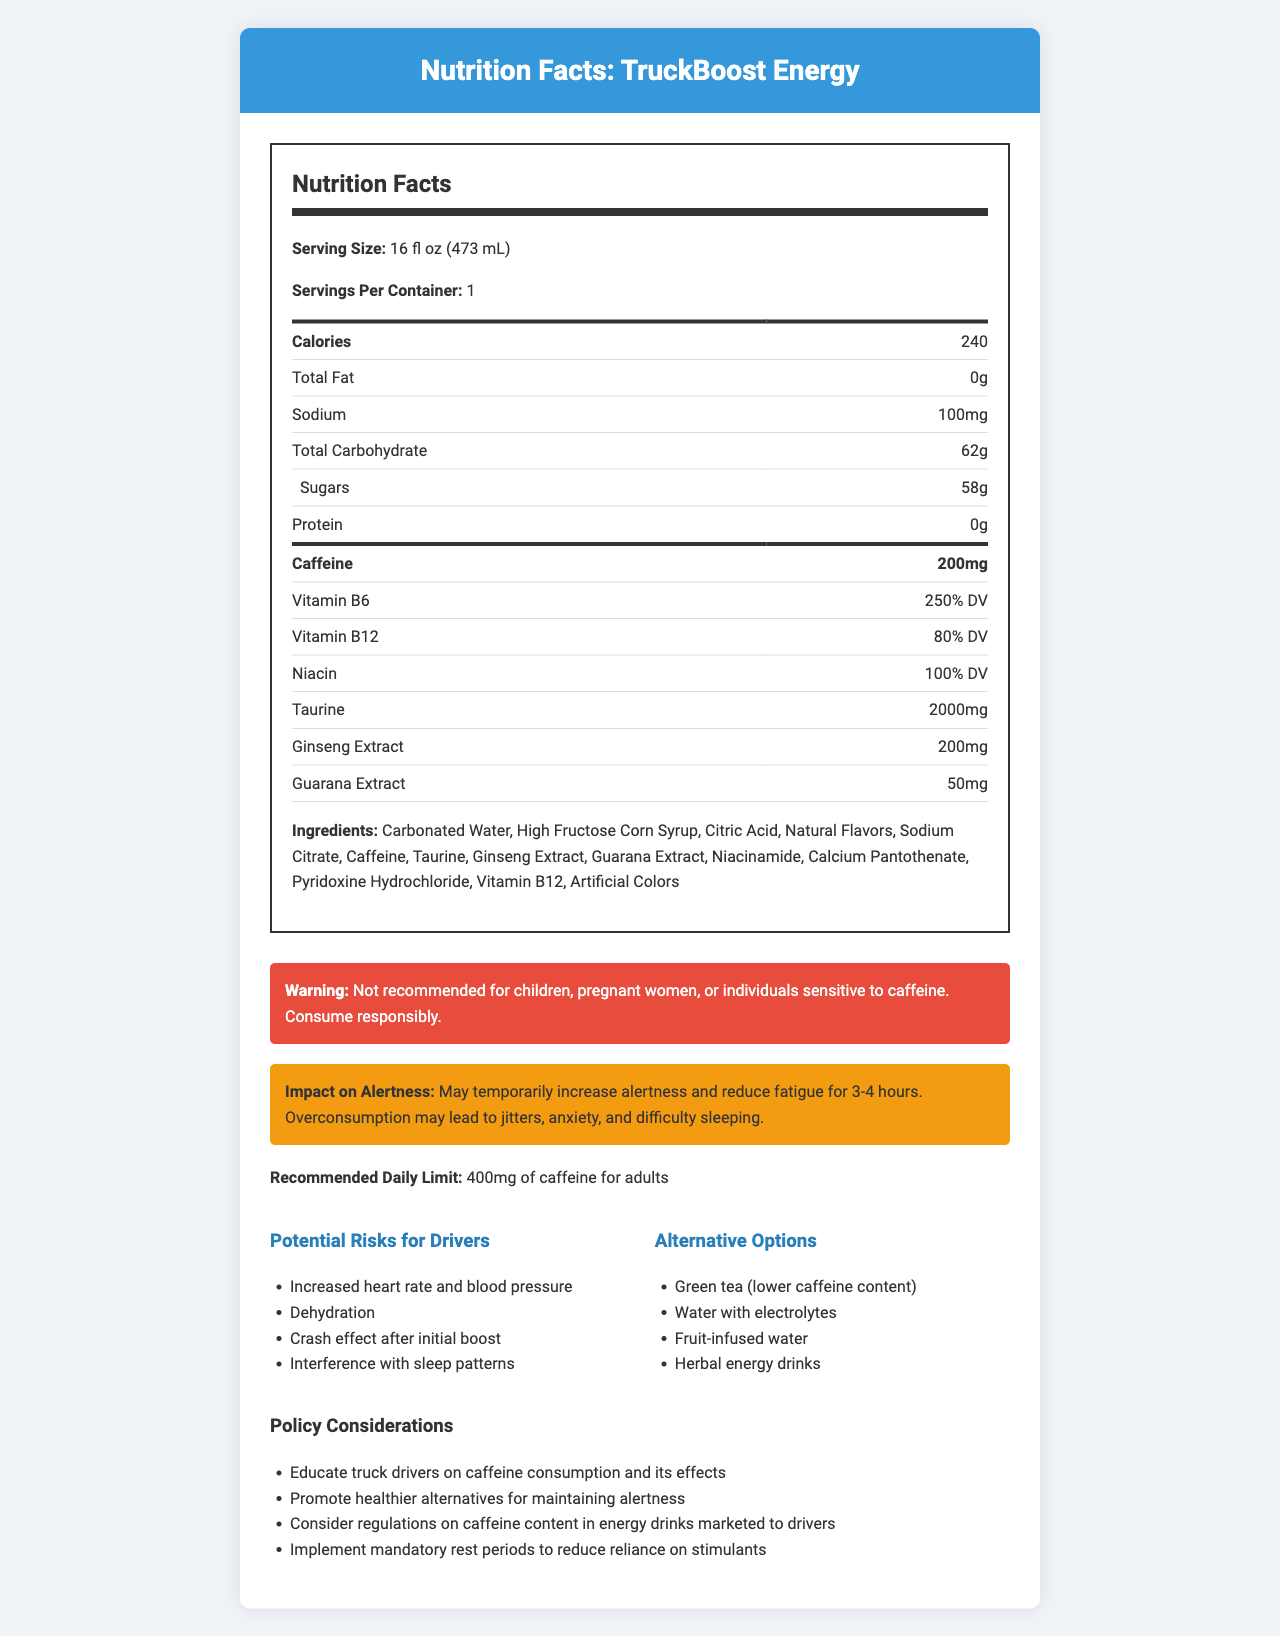What is the serving size of TruckBoost Energy? The serving size is clearly listed at the top of the Nutrition Facts label.
Answer: 16 fl oz (473 mL) How many grams of sugar are in one serving of TruckBoost Energy? The sugar content is listed under the Total Carbohydrate section as 58 grams.
Answer: 58g How much caffeine does each can of TruckBoost Energy contain? The caffeine content is highlighted in the Nutrition Facts section with 200mg.
Answer: 200mg What is the sodium content per serving? The sodium content is stated as 100mg in the Nutrition Facts label.
Answer: 100mg How many calories are in one serving of TruckBoost Energy? The calorie content is listed at the top of the Nutrition Facts label with 240 calories.
Answer: 240 What percentage of the Daily Value of Vitamin B6 is in TruckBoost Energy? The Vitamin B6 content is given as 250% of the Daily Value in the Nutrition Facts.
Answer: 250% DV What is the recommended daily limit for caffeine intake? The recommended daily limit for caffeine is mentioned towards the bottom of the document.
Answer: 400mg of caffeine for adults Which of the following is NOT an ingredient in TruckBoost Energy? A. Citric Acid B. Ginseng Extract C. Maltodextrin D. High Fructose Corn Syrup The list of ingredients includes Citric Acid, Ginseng Extract, and High Fructose Corn Syrup but does not include Maltodextrin.
Answer: C. Maltodextrin Which of the following are potential risks for drivers consuming TruckBoost Energy? (Select all that apply) 1. Increased heart rate and blood pressure 2. Enhanced cognitive function 3. Dehydration 4. Improved sleep quality The potential risks listed in the document for drivers include increased heart rate and blood pressure, and dehydration.
Answer: 1 and 3 Is TruckBoost Energy recommended for children? The warning section specifies that it is not recommended for children, pregnant women, or individuals sensitive to caffeine.
Answer: No Summarize the main idea of the document. The summary covers the key points presented in the document, including nutritional facts, caffeine effects, risks, alternatives, and policy considerations.
Answer: The document provides detailed nutritional information about TruckBoost Energy, a popular energy drink among truck drivers. It highlights the high caffeine content and its potential effects on alertness, as well as the health risks associated with overconsumption. The document also suggests alternative healthier options and includes policy considerations for regulating caffeine intake among drivers. Can TruckBoost Energy cause weight gain? The document does not provide specific information about weight gain.
Answer: Cannot be determined What are some healthier alternatives to TruckBoost Energy for maintaining alertness? These alternatives are listed in the document as healthier options for maintaining alertness.
Answer: Green tea, Water with electrolytes, Fruit-infused water, Herbal energy drinks What regulatory measure is suggested to control caffeine intake among drivers? One of the policy considerations mentioned in the document is the regulation of caffeine content in energy drinks marketed to drivers.
Answer: Consider regulations on caffeine content in energy drinks marketed to drivers How long does the alertness effect of TruckBoost Energy typically last? According to the document, the alertness effect may last for 3-4 hours.
Answer: 3-4 hours 